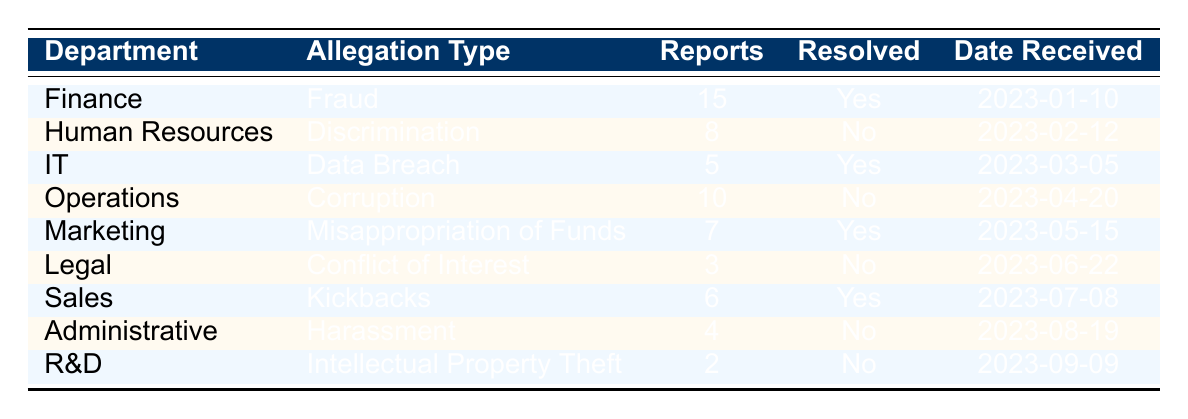What is the total number of whistleblower reports filed in the Finance department? The table shows that there are 15 reports under the Finance department. Therefore, the total number of reports filed in this department is 15.
Answer: 15 How many allegations of Discrimination were unresolved? Referring to the table, there are 8 reports related to Discrimination under the Human Resources department, and they are marked as unresolved. Therefore, the number of unresolved allegations of Discrimination is 8.
Answer: 8 What percentage of allegations in Operations are resolved? In the table, the Operations department has 10 reports related to Corruption, and none (0) are resolved. The calculation for percentage is (0 resolved / 10 total reports) * 100 = 0%. Thus, the percentage of resolved allegations in Operations is 0%.
Answer: 0% Which department received the first whistleblower report and what type of allegation was it? The table indicates that the first report was received by the Finance department on 2023-01-10 for the allegation type of Fraud. Thus, the department and type of allegation for the first report are Finance and Fraud respectively.
Answer: Finance, Fraud How many total unresolved allegations are there across all departments? Looking at the table, the unresolved allegations can be summed up: Human Resources (8) + Operations (10) + Legal (3) + Administrative (4) + R&D (2) = 27. Therefore, the total number of unresolved allegations across all departments is 27.
Answer: 27 Were there any departments that had resolved allegations? By reviewing the table, it is clear that Finance, IT, Marketing, and Sales departments all have resolved allegations. Therefore, the answer is yes, there are departments with resolved allegations.
Answer: Yes What is the minimum number of reports filed in any department? From the table, the department with the least number of reports is R&D, which has 2 reports under the allegation type of Intellectual Property Theft. Thus, the minimum number of reports filed in any department is 2.
Answer: 2 Which departments have resolved allegations, and how many reports were there in total from these departments? Referring to the table, the departments with resolved allegations are Finance (15), IT (5), Marketing (7), and Sales (6). Summing these values gives: 15 + 5 + 7 + 6 = 33 reports. Therefore, the total number of reports from departments that have resolved allegations is 33.
Answer: 33 